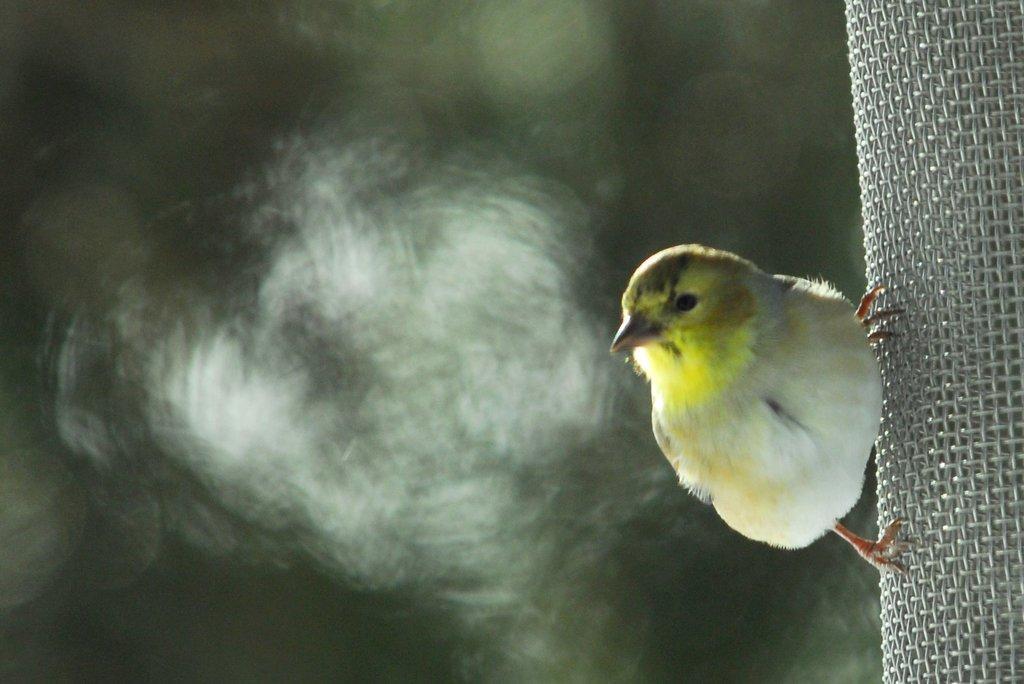Could you give a brief overview of what you see in this image? On the right side of the image we can see a bird on the mesh. In the background, the image is blurred. 